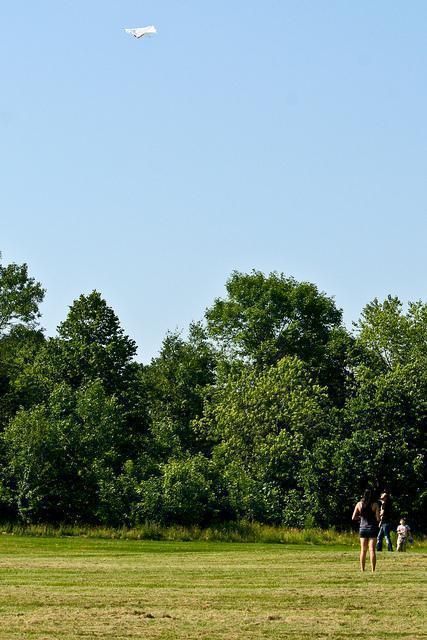What are the people standing in front of?
Make your selection from the four choices given to correctly answer the question.
Options: Cats, trees, book shelves, apples. Trees. 